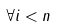Convert formula to latex. <formula><loc_0><loc_0><loc_500><loc_500>\forall i < n</formula> 